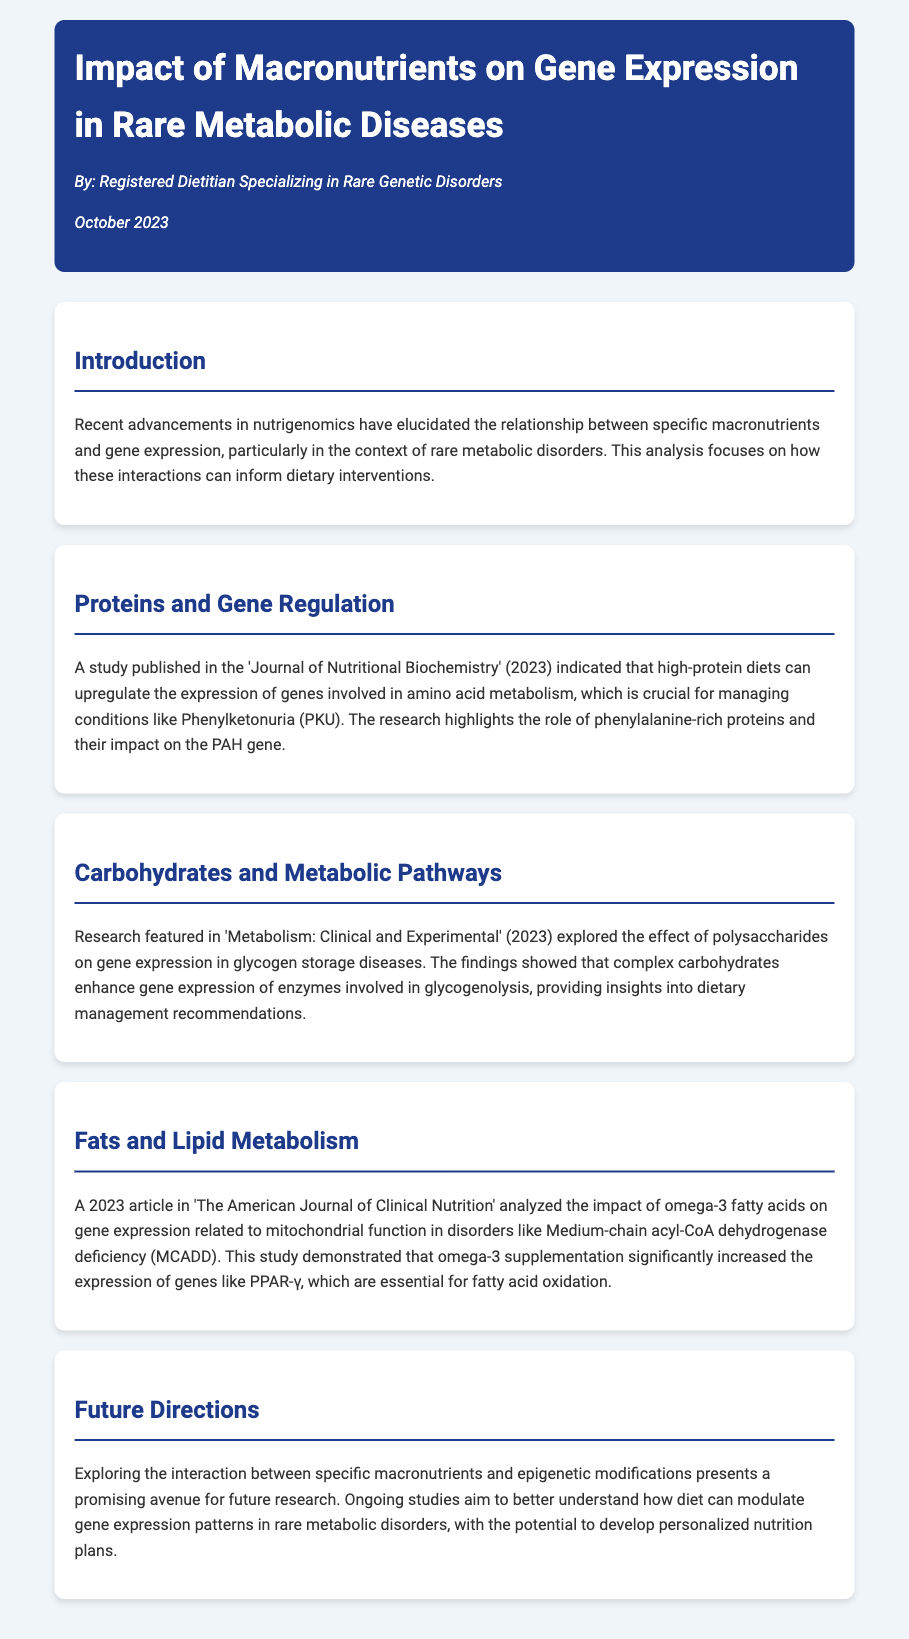What is the main focus of the analysis? The analysis focuses on the relationship between specific macronutrients and gene expression in rare metabolic disorders.
Answer: Relationship between specific macronutrients and gene expression in rare metabolic disorders What gene is impacted by phenylalanine-rich proteins? The gene impacted by phenylalanine-rich proteins is the PAH gene.
Answer: PAH gene Which publication discussed the effect of complex carbohydrates on gene expression? The publication that discussed complex carbohydrates is 'Metabolism: Clinical and Experimental'.
Answer: Metabolism: Clinical and Experimental What type of fatty acids were analyzed in relation to mitochondrial function? The type of fatty acids analyzed were omega-3 fatty acids.
Answer: Omega-3 fatty acids What potential future research area is mentioned? The potential future research area mentioned is the interaction between specific macronutrients and epigenetic modifications.
Answer: Interaction between specific macronutrients and epigenetic modifications 